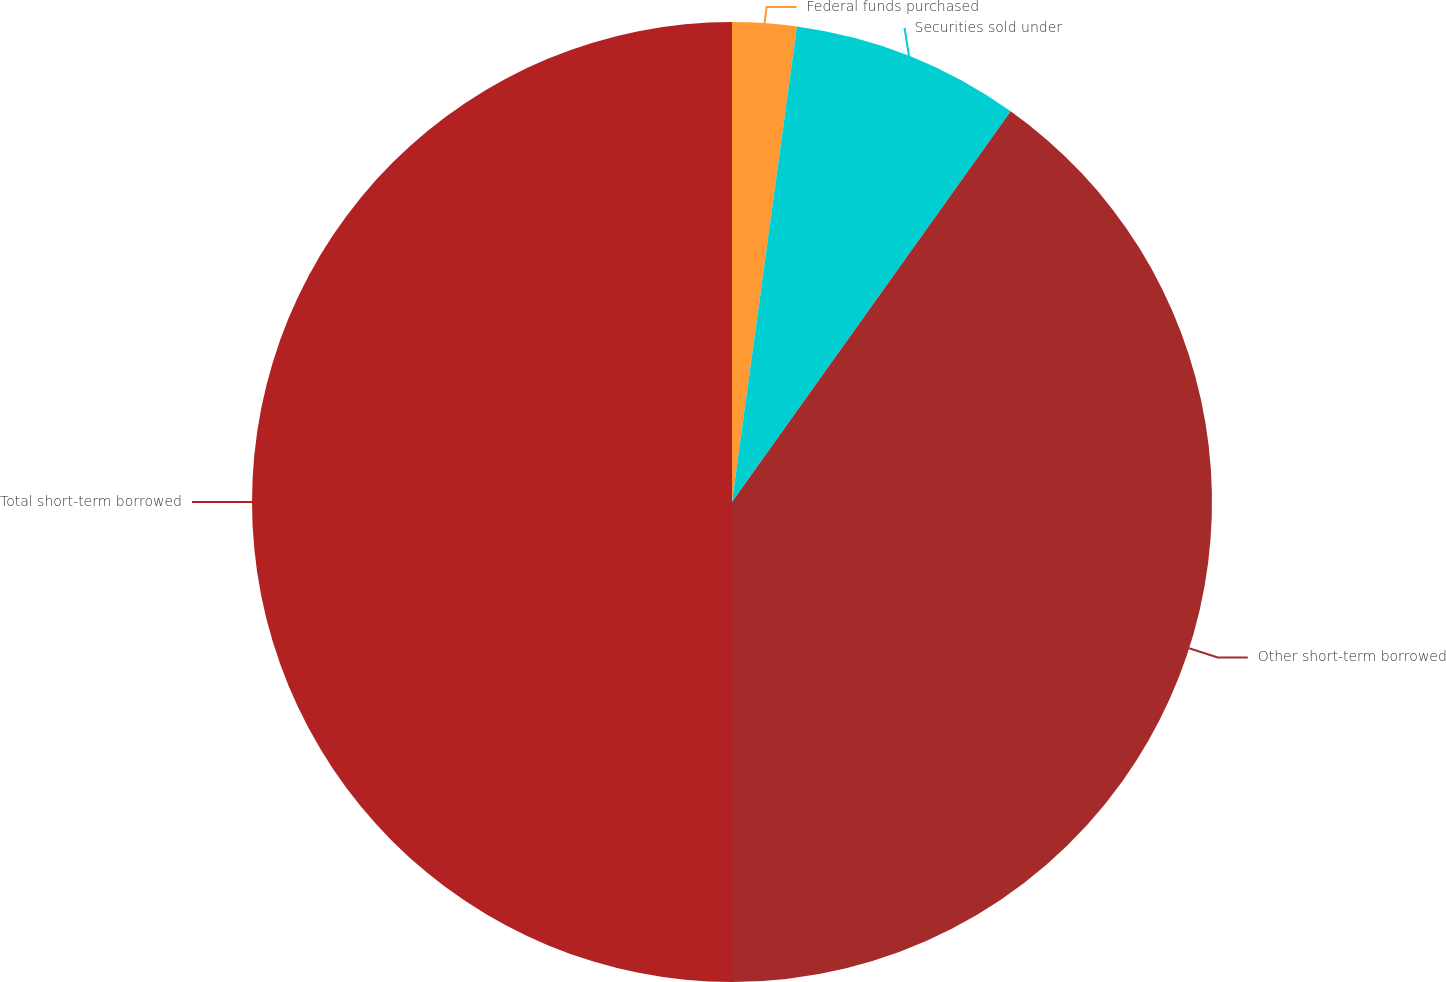Convert chart to OTSL. <chart><loc_0><loc_0><loc_500><loc_500><pie_chart><fcel>Federal funds purchased<fcel>Securities sold under<fcel>Other short-term borrowed<fcel>Total short-term borrowed<nl><fcel>2.16%<fcel>7.7%<fcel>40.14%<fcel>50.0%<nl></chart> 